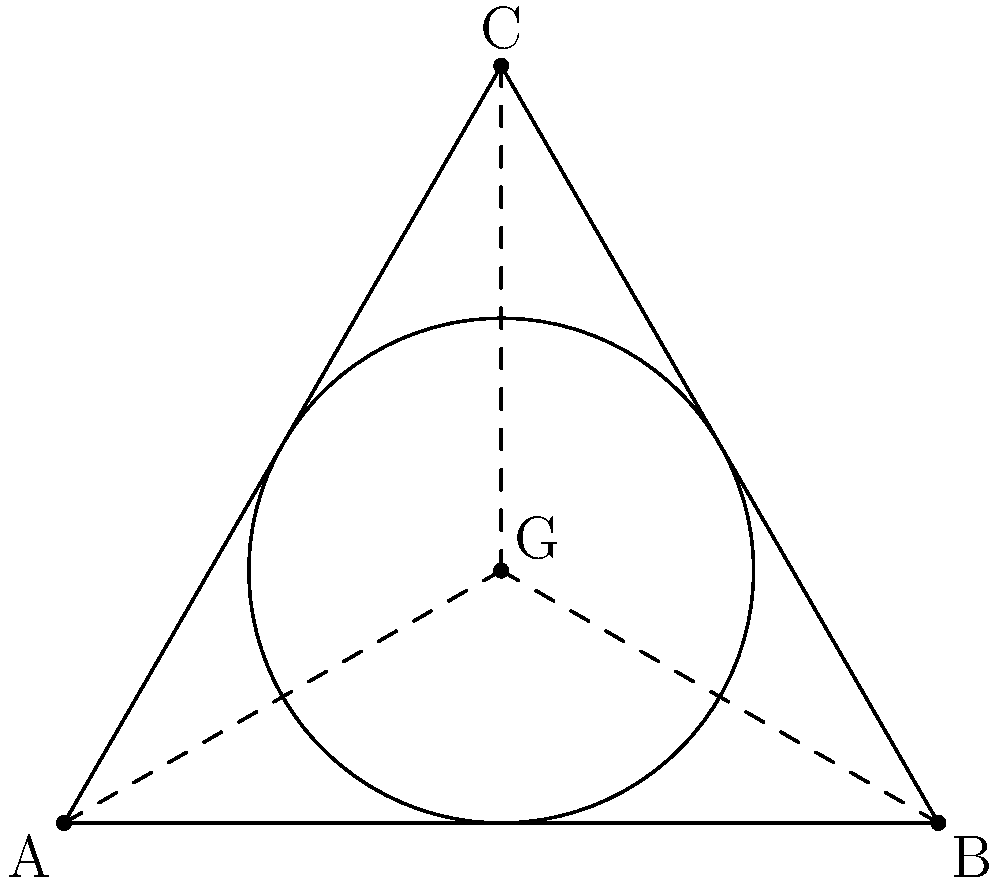Three Wushu practitioners form an equilateral triangle with side length 4 meters during a performance. If they want to inscribe a circular stage within this triangle, what would be the radius of this stage? Let's approach this step-by-step:

1) In an equilateral triangle, the radius of the inscribed circle is given by the formula:

   $$r = \frac{a}{2\sqrt{3}}$$

   where $r$ is the radius and $a$ is the side length of the triangle.

2) We are given that the side length of the triangle is 4 meters. Let's substitute this into our formula:

   $$r = \frac{4}{2\sqrt{3}}$$

3) Simplify:
   
   $$r = \frac{2}{\sqrt{3}}$$

4) To simplify further, we can rationalize the denominator:

   $$r = \frac{2}{\sqrt{3}} \cdot \frac{\sqrt{3}}{\sqrt{3}} = \frac{2\sqrt{3}}{3}$$

5) This can be left as is, or we can calculate the decimal approximation:

   $$r \approx 1.1547$$ meters

Therefore, the radius of the inscribed circle (the circular stage) would be $\frac{2\sqrt{3}}{3}$ meters, or approximately 1.1547 meters.
Answer: $\frac{2\sqrt{3}}{3}$ meters 